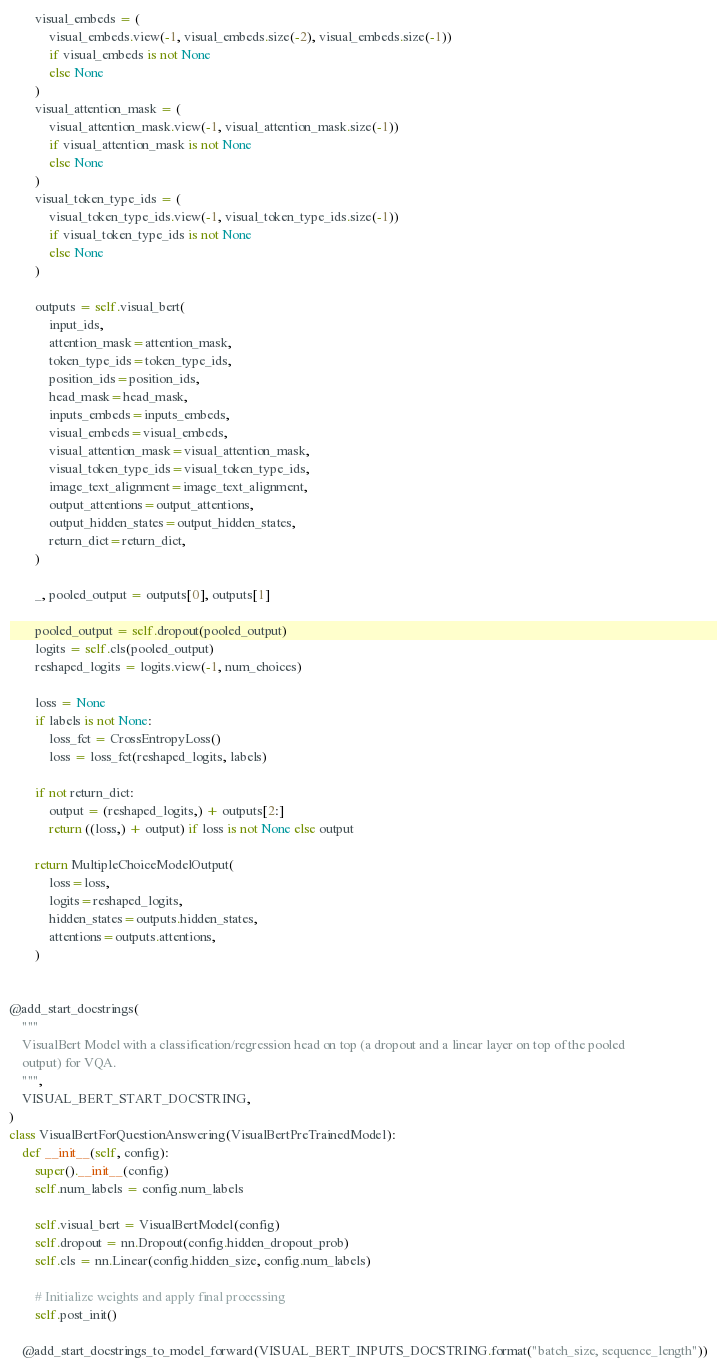Convert code to text. <code><loc_0><loc_0><loc_500><loc_500><_Python_>        visual_embeds = (
            visual_embeds.view(-1, visual_embeds.size(-2), visual_embeds.size(-1))
            if visual_embeds is not None
            else None
        )
        visual_attention_mask = (
            visual_attention_mask.view(-1, visual_attention_mask.size(-1))
            if visual_attention_mask is not None
            else None
        )
        visual_token_type_ids = (
            visual_token_type_ids.view(-1, visual_token_type_ids.size(-1))
            if visual_token_type_ids is not None
            else None
        )

        outputs = self.visual_bert(
            input_ids,
            attention_mask=attention_mask,
            token_type_ids=token_type_ids,
            position_ids=position_ids,
            head_mask=head_mask,
            inputs_embeds=inputs_embeds,
            visual_embeds=visual_embeds,
            visual_attention_mask=visual_attention_mask,
            visual_token_type_ids=visual_token_type_ids,
            image_text_alignment=image_text_alignment,
            output_attentions=output_attentions,
            output_hidden_states=output_hidden_states,
            return_dict=return_dict,
        )

        _, pooled_output = outputs[0], outputs[1]

        pooled_output = self.dropout(pooled_output)
        logits = self.cls(pooled_output)
        reshaped_logits = logits.view(-1, num_choices)

        loss = None
        if labels is not None:
            loss_fct = CrossEntropyLoss()
            loss = loss_fct(reshaped_logits, labels)

        if not return_dict:
            output = (reshaped_logits,) + outputs[2:]
            return ((loss,) + output) if loss is not None else output

        return MultipleChoiceModelOutput(
            loss=loss,
            logits=reshaped_logits,
            hidden_states=outputs.hidden_states,
            attentions=outputs.attentions,
        )


@add_start_docstrings(
    """
    VisualBert Model with a classification/regression head on top (a dropout and a linear layer on top of the pooled
    output) for VQA.
    """,
    VISUAL_BERT_START_DOCSTRING,
)
class VisualBertForQuestionAnswering(VisualBertPreTrainedModel):
    def __init__(self, config):
        super().__init__(config)
        self.num_labels = config.num_labels

        self.visual_bert = VisualBertModel(config)
        self.dropout = nn.Dropout(config.hidden_dropout_prob)
        self.cls = nn.Linear(config.hidden_size, config.num_labels)

        # Initialize weights and apply final processing
        self.post_init()

    @add_start_docstrings_to_model_forward(VISUAL_BERT_INPUTS_DOCSTRING.format("batch_size, sequence_length"))</code> 